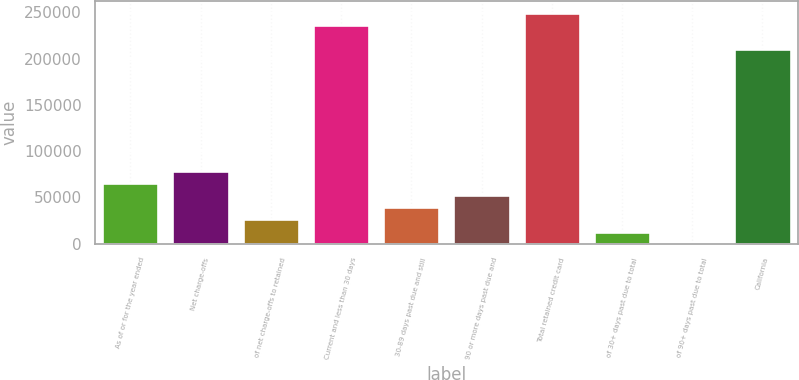Convert chart to OTSL. <chart><loc_0><loc_0><loc_500><loc_500><bar_chart><fcel>As of or for the year ended<fcel>Net charge-offs<fcel>of net charge-offs to retained<fcel>Current and less than 30 days<fcel>30-89 days past due and still<fcel>90 or more days past due and<fcel>Total retained credit card<fcel>of 30+ days past due to total<fcel>of 90+ days past due to total<fcel>California<nl><fcel>65693.9<fcel>78832.5<fcel>26278<fcel>236496<fcel>39416.6<fcel>52555.2<fcel>249635<fcel>13139.4<fcel>0.72<fcel>210219<nl></chart> 